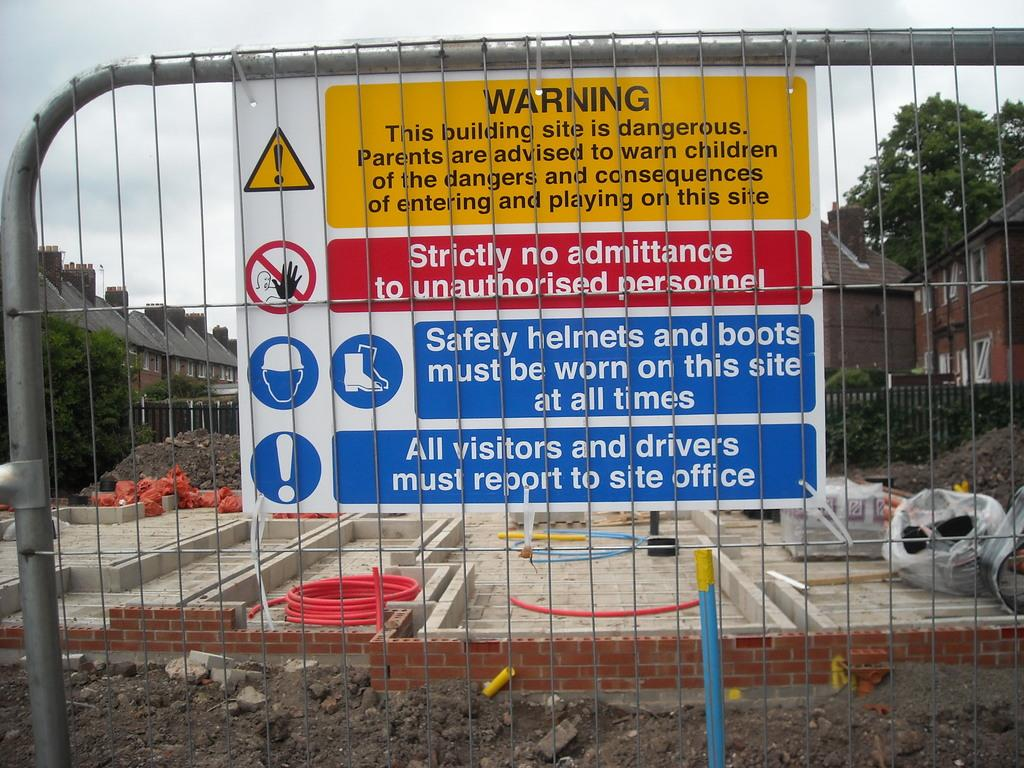<image>
Summarize the visual content of the image. A Warning sign attached to fence says Strictly No Admittance to unauthorized personnel. 